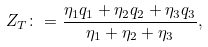Convert formula to latex. <formula><loc_0><loc_0><loc_500><loc_500>Z _ { T } \colon = \frac { \eta _ { 1 } q _ { 1 } + \eta _ { 2 } q _ { 2 } + \eta _ { 3 } q _ { 3 } } { \eta _ { 1 } + \eta _ { 2 } + \eta _ { 3 } } ,</formula> 